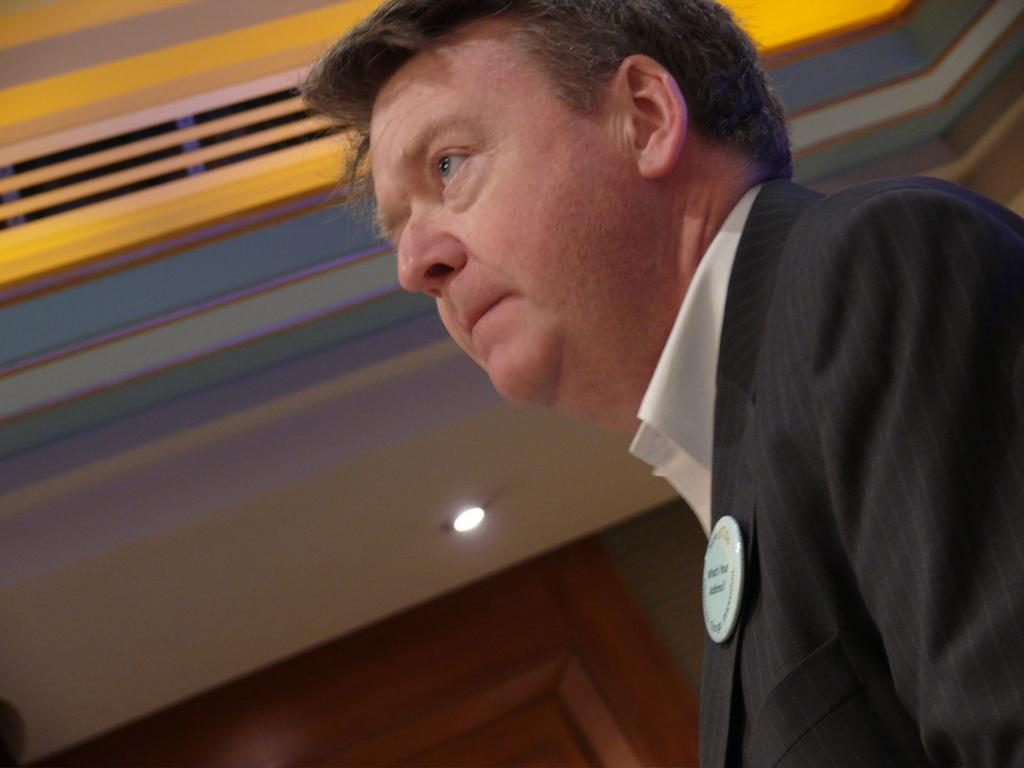What is the main subject in the foreground of the image? There is a person in the foreground of the image. What can be seen in the background of the image? There is a door, a wall, and a light visible in the background of the image. What is the ceiling like in the image? There is a ceiling visible at the top of the image. What riddle is the person in the image trying to solve? There is no riddle present in the image; it only shows a person in the foreground and various elements in the background. 